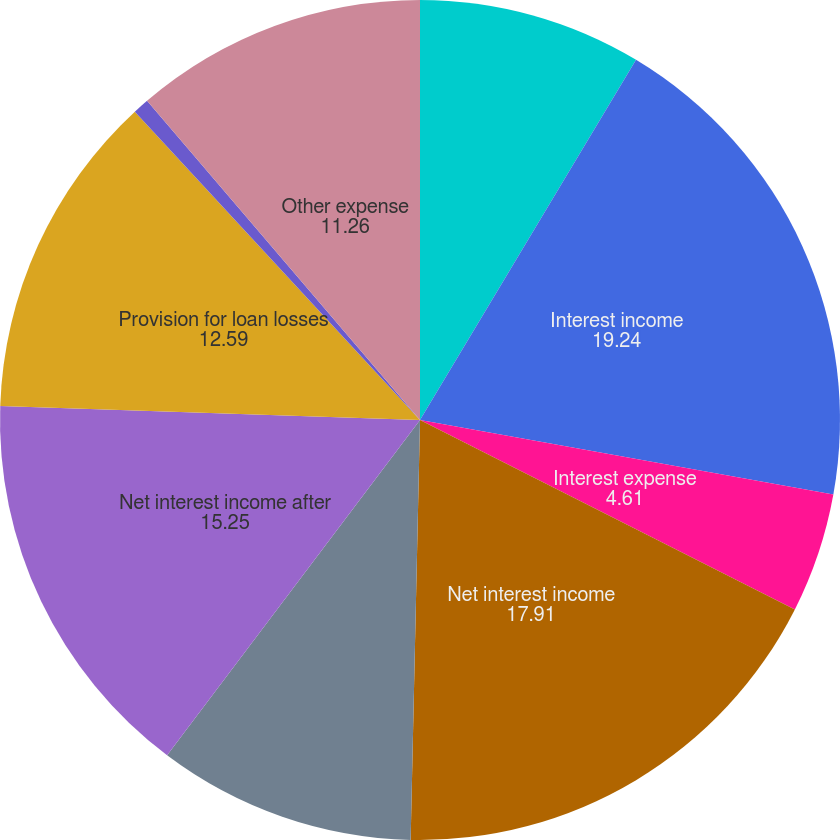Convert chart to OTSL. <chart><loc_0><loc_0><loc_500><loc_500><pie_chart><fcel>( in millions except per share<fcel>Interest income<fcel>Interest expense<fcel>Net interest income<fcel>Retailer share arrangements<fcel>Net interest income after<fcel>Provision for loan losses<fcel>Other income<fcel>Other expense<nl><fcel>8.6%<fcel>19.24%<fcel>4.61%<fcel>17.91%<fcel>9.93%<fcel>15.25%<fcel>12.59%<fcel>0.62%<fcel>11.26%<nl></chart> 